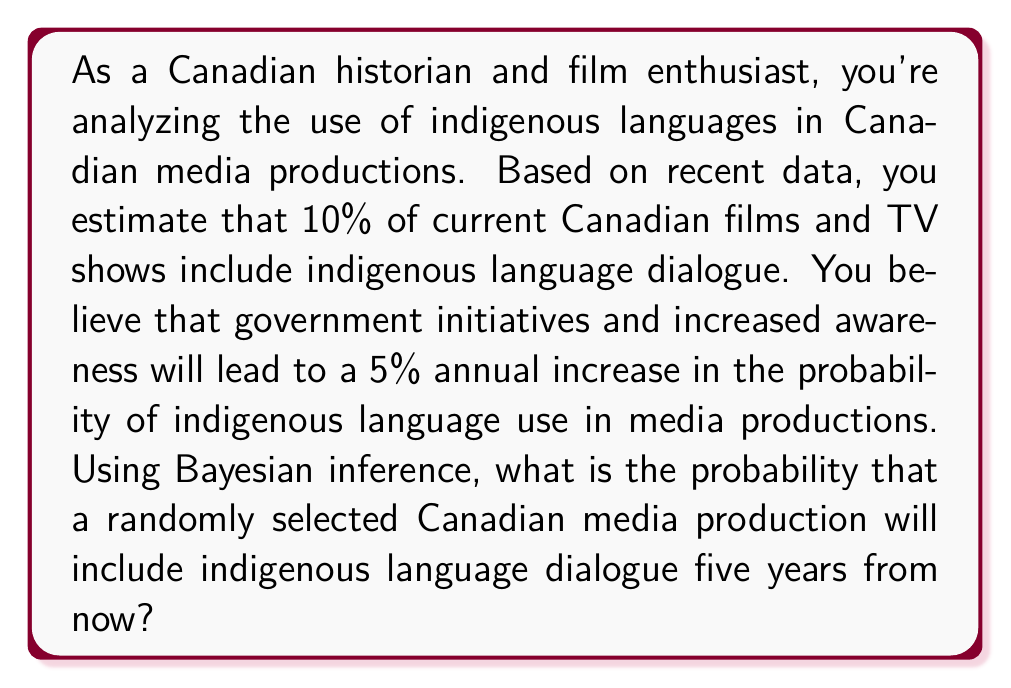Provide a solution to this math problem. To solve this problem, we'll use Bayesian inference and the concept of conditional probability. Let's break it down step-by-step:

1. Define our variables:
   $p_0$ = initial probability of indigenous language use (10% or 0.10)
   $r$ = annual rate of increase (5% or 0.05)
   $n$ = number of years (5)

2. We need to calculate the probability after 5 years. The probability increases by 5% of the remaining probability each year. This can be modeled as:

   $p_n = 1 - (1 - p_0)(1 - r)^n$

3. Let's substitute our values:

   $p_5 = 1 - (1 - 0.10)(1 - 0.05)^5$

4. Simplify:
   $p_5 = 1 - (0.90)(0.95)^5$
   $p_5 = 1 - (0.90)(0.7738)$
   $p_5 = 1 - 0.6964$
   $p_5 = 0.3036$

5. Convert to a percentage:
   $0.3036 * 100 = 30.36\%$

This means that after 5 years, there's a 30.36% chance that a randomly selected Canadian media production will include indigenous language dialogue.
Answer: The probability that a randomly selected Canadian media production will include indigenous language dialogue five years from now is approximately 30.36%. 